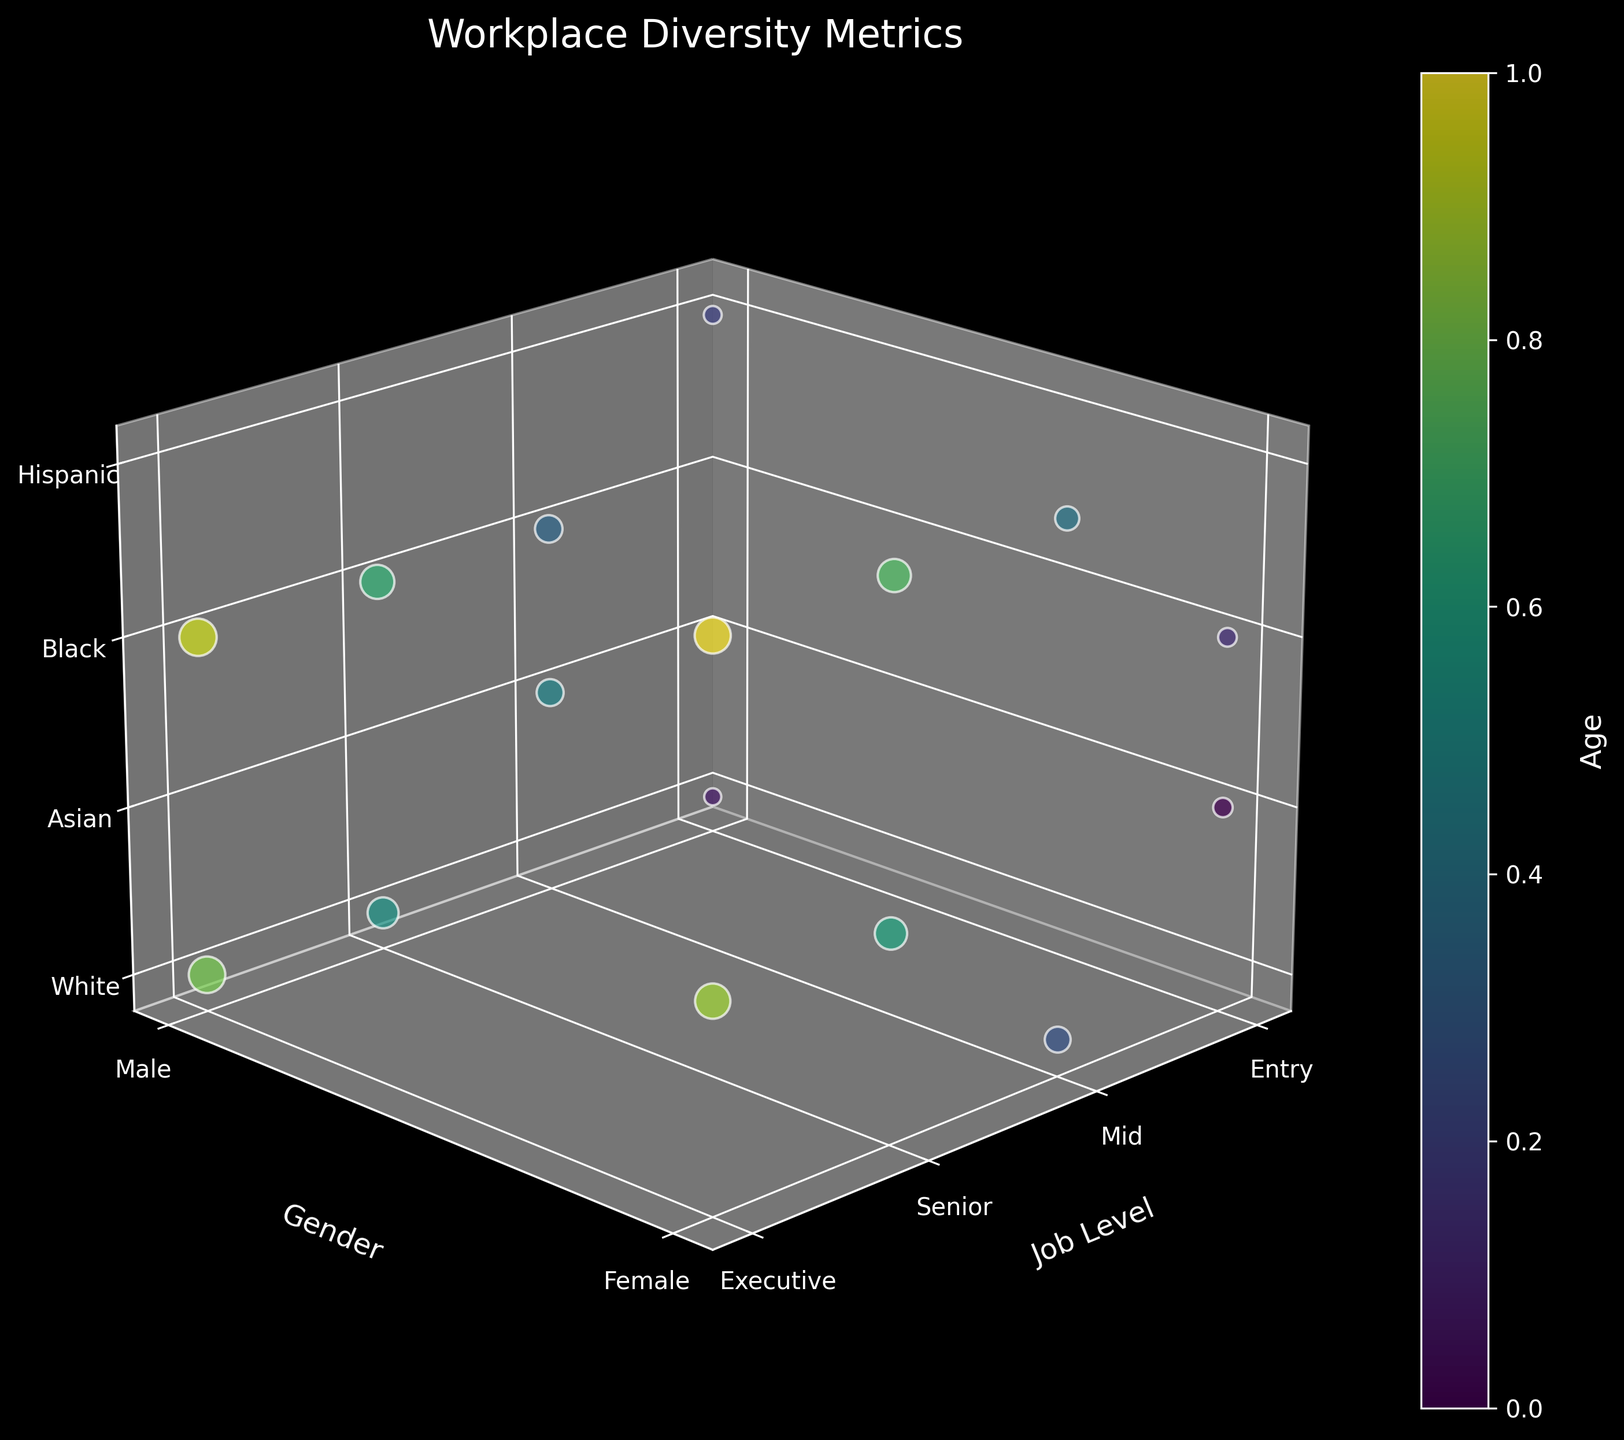What is the title of the figure? The title of a figure is typically displayed at the top center. In this case, it reads "Workplace Diversity Metrics".
Answer: Workplace Diversity Metrics What does the color bar represent? The color bar next to the scatter plot indicates the range of ages in the dataset, as labeled on the plot.
Answer: Age Which axis represents the job levels? The axis labeled 'Job Level' corresponds to the x-axis. The xticks labels also indicate different job levels.
Answer: x-axis At the Executive level, which ethnicity has the highest average age? Identify all data points at the Executive level, then compare the ages for each ethnicity. The highest age values belong to the Black ethnicity.
Answer: Black Between the Entry Level and Senior Level, which has more data points for females? Count the data points representing females at both Entry Level and Senior Level. Entry Level has 3 points, and Senior Level has 2 points.
Answer: Entry Level How many ethnicities are represented in the Mid-Level job level? Count the number of distinct z-tick values for Mid-Level data points. There are 4 (White, Black, Asian, Hispanic).
Answer: 4 At what job level is the youngest male employee found? Cross-reference the minimum age among males against their job levels, identifying the Entry Level for a 22-year-old.
Answer: Entry Level Do males outnumber females at the Senior Level? Compare the count of male versus female data points at the Senior Level. There are 2 males and 2 females at this level.
Answer: No Is there an ethnicity not represented at the Executive level? Check all represented ethnicities at the Executive level and cross-check against the list (White, Asian, Black, Hispanic). All ethnicities are represented.
Answer: No Which job level shows the most diversity in gender? Compare the number of distinct gender categories at each job level. All levels (Entry, Mid, Senior, Executive) show both male and female categories, thus similar in gender diversity.
Answer: All job levels are equal 